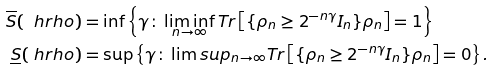<formula> <loc_0><loc_0><loc_500><loc_500>\overline { S } ( \ h r h o ) & = \inf \left \{ \gamma \colon \liminf _ { n \rightarrow \infty } T r \left [ \{ \rho _ { n } \geq 2 ^ { - n \gamma } I _ { n } \} \rho _ { n } \right ] = 1 \right \} \\ \underline { S } ( \ h r h o ) & = \sup \left \{ \gamma \colon \lim s u p _ { n \rightarrow \infty } T r \left [ \{ \rho _ { n } \geq 2 ^ { - n \gamma } I _ { n } \} \rho _ { n } \right ] = 0 \right \} .</formula> 